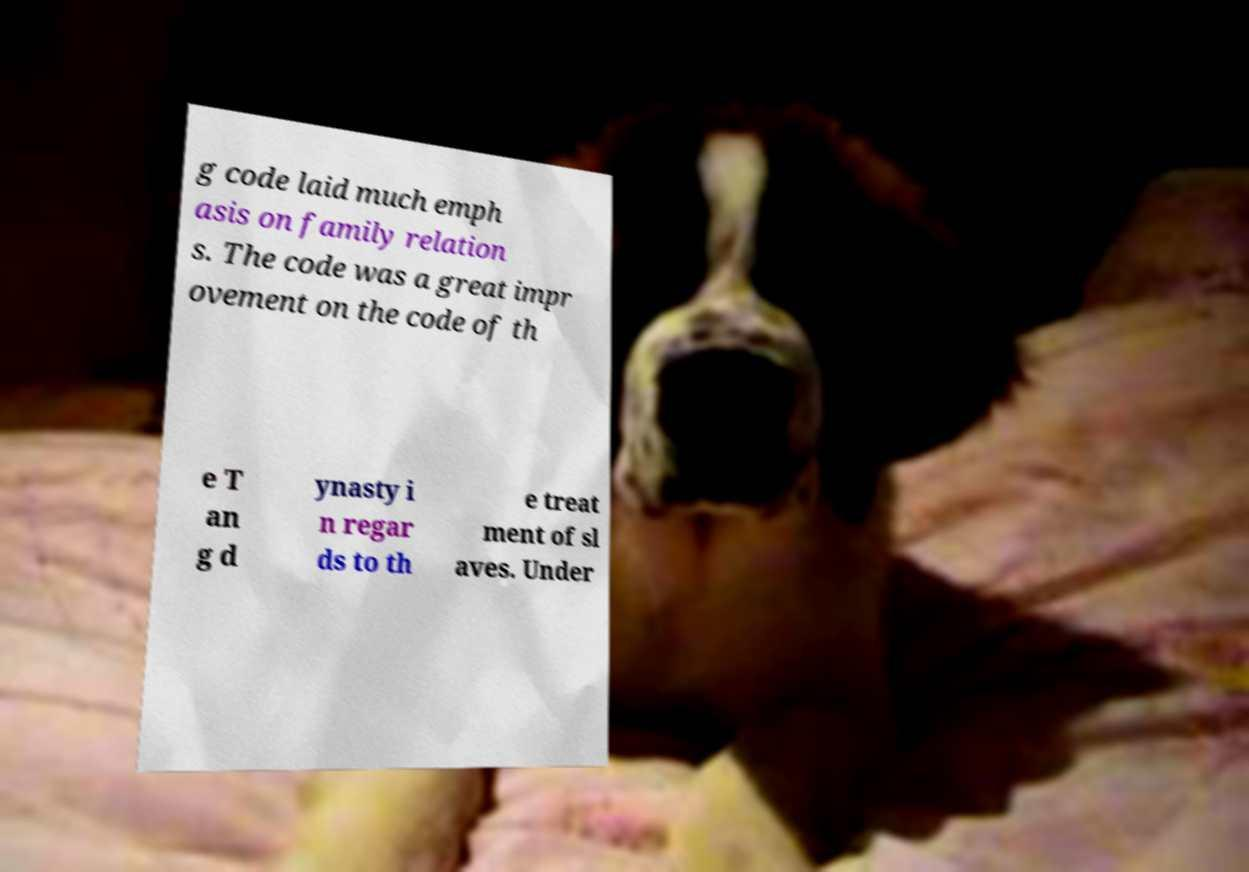Could you extract and type out the text from this image? g code laid much emph asis on family relation s. The code was a great impr ovement on the code of th e T an g d ynasty i n regar ds to th e treat ment of sl aves. Under 